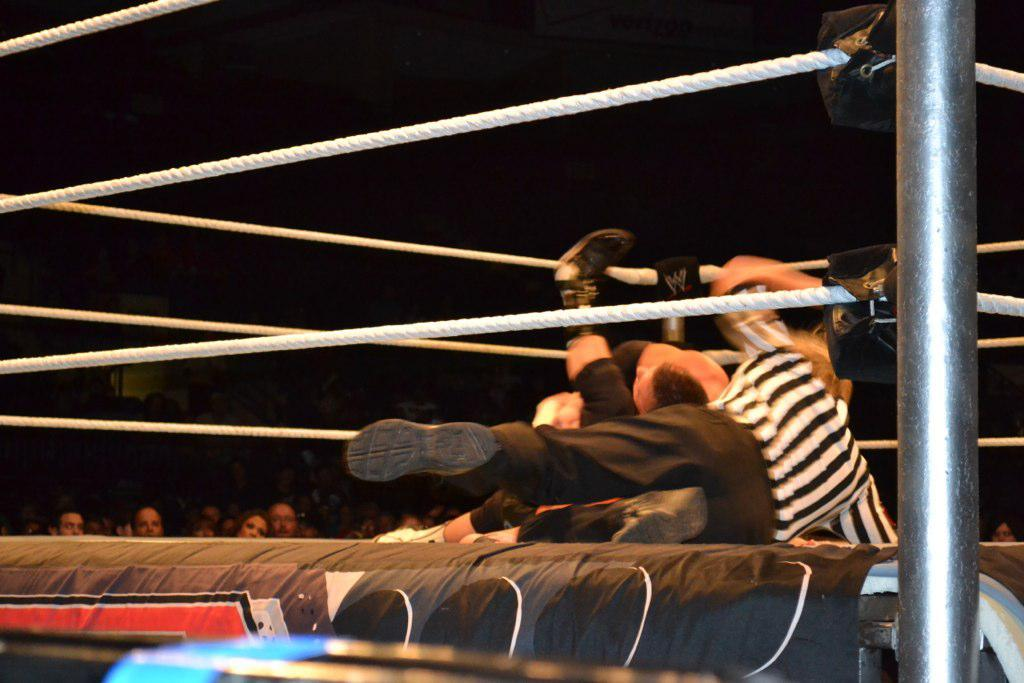What type of court is shown in the image? There is a kickboxing court in the image. What are the two persons on the court doing? The two persons are performing a show on the court. What is the empire present in the image? There is an empire present in the image, which might refer to a group of people or a team. Who is observing the show being performed on the court? Some people are watching the show. What type of fruit is being used as a cannonball in the image? There is no fruit or cannon present in the image. What type of bread is being used as a prop in the show? There is no bread present in the image, and no props are mentioned in the provided facts. 